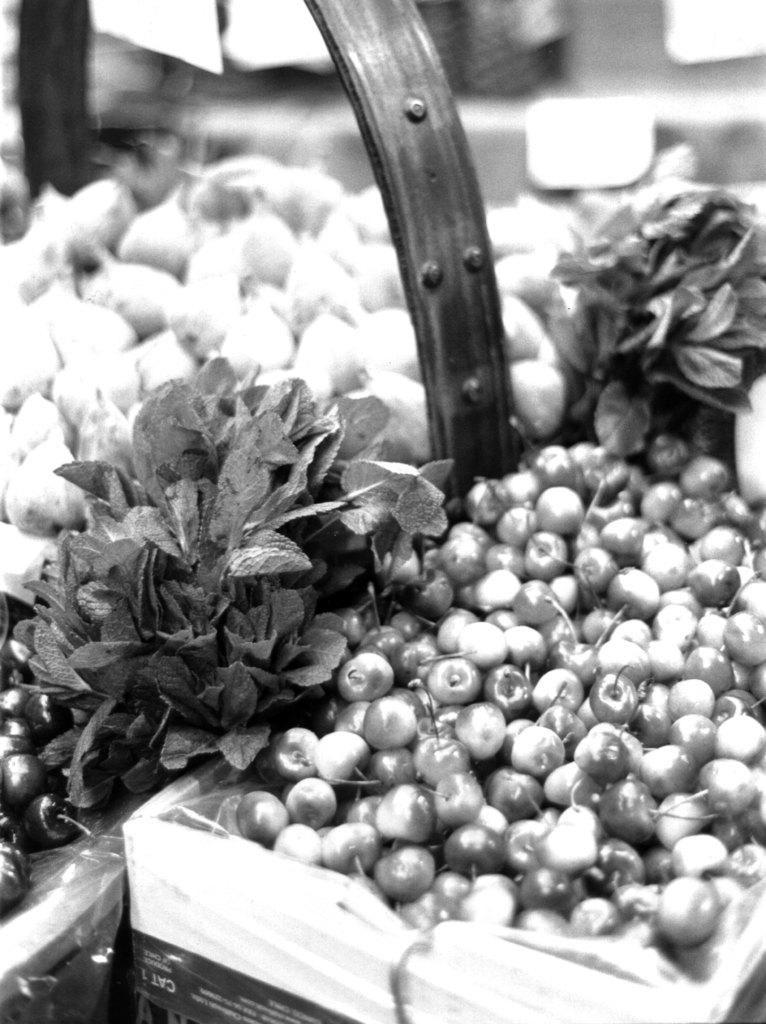What is the color scheme of the image? The image is black and white. What can be seen in the baskets in the image? There are fruits in the baskets in the image. What type of plant material is present in the image? There are leaves in the image. How would you describe the overall lighting or brightness of the image? The background of the image is dark. Can you hear the bushes crying in the image? There are no bushes or sounds in the image, so it is not possible to hear any crying. 